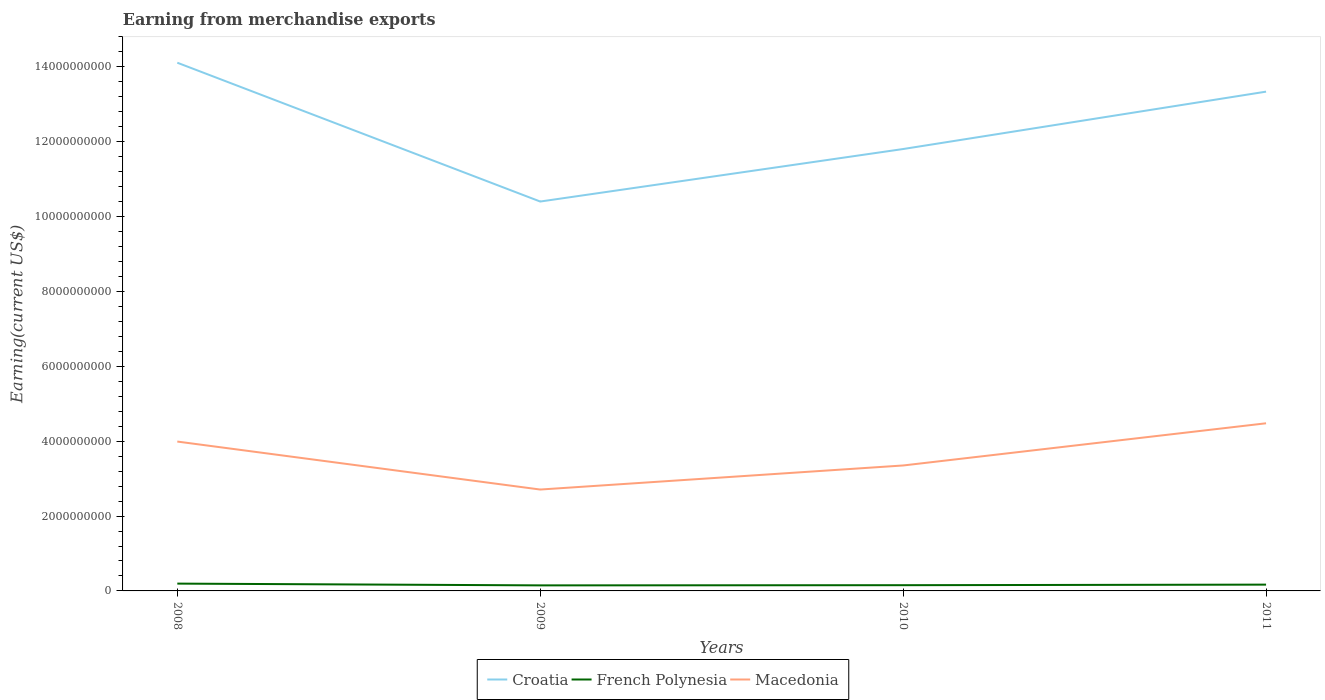How many different coloured lines are there?
Ensure brevity in your answer.  3. Is the number of lines equal to the number of legend labels?
Keep it short and to the point. Yes. Across all years, what is the maximum amount earned from merchandise exports in Croatia?
Ensure brevity in your answer.  1.04e+1. In which year was the amount earned from merchandise exports in Croatia maximum?
Make the answer very short. 2009. What is the total amount earned from merchandise exports in Croatia in the graph?
Keep it short and to the point. -2.94e+09. What is the difference between the highest and the second highest amount earned from merchandise exports in French Polynesia?
Ensure brevity in your answer.  4.72e+07. What is the difference between the highest and the lowest amount earned from merchandise exports in Macedonia?
Your response must be concise. 2. How many lines are there?
Provide a succinct answer. 3. Does the graph contain any zero values?
Give a very brief answer. No. Does the graph contain grids?
Provide a succinct answer. No. Where does the legend appear in the graph?
Provide a succinct answer. Bottom center. How many legend labels are there?
Your answer should be compact. 3. How are the legend labels stacked?
Keep it short and to the point. Horizontal. What is the title of the graph?
Your answer should be very brief. Earning from merchandise exports. What is the label or title of the X-axis?
Provide a succinct answer. Years. What is the label or title of the Y-axis?
Your answer should be very brief. Earning(current US$). What is the Earning(current US$) of Croatia in 2008?
Your answer should be very brief. 1.41e+1. What is the Earning(current US$) of French Polynesia in 2008?
Ensure brevity in your answer.  1.95e+08. What is the Earning(current US$) of Macedonia in 2008?
Your response must be concise. 3.99e+09. What is the Earning(current US$) of Croatia in 2009?
Offer a terse response. 1.04e+1. What is the Earning(current US$) of French Polynesia in 2009?
Your response must be concise. 1.48e+08. What is the Earning(current US$) in Macedonia in 2009?
Provide a short and direct response. 2.71e+09. What is the Earning(current US$) in Croatia in 2010?
Your answer should be very brief. 1.18e+1. What is the Earning(current US$) in French Polynesia in 2010?
Make the answer very short. 1.53e+08. What is the Earning(current US$) of Macedonia in 2010?
Give a very brief answer. 3.35e+09. What is the Earning(current US$) in Croatia in 2011?
Give a very brief answer. 1.33e+1. What is the Earning(current US$) in French Polynesia in 2011?
Give a very brief answer. 1.68e+08. What is the Earning(current US$) in Macedonia in 2011?
Your answer should be compact. 4.48e+09. Across all years, what is the maximum Earning(current US$) in Croatia?
Make the answer very short. 1.41e+1. Across all years, what is the maximum Earning(current US$) in French Polynesia?
Your response must be concise. 1.95e+08. Across all years, what is the maximum Earning(current US$) of Macedonia?
Your response must be concise. 4.48e+09. Across all years, what is the minimum Earning(current US$) of Croatia?
Your answer should be compact. 1.04e+1. Across all years, what is the minimum Earning(current US$) of French Polynesia?
Offer a very short reply. 1.48e+08. Across all years, what is the minimum Earning(current US$) in Macedonia?
Provide a succinct answer. 2.71e+09. What is the total Earning(current US$) in Croatia in the graph?
Your answer should be very brief. 4.97e+1. What is the total Earning(current US$) of French Polynesia in the graph?
Give a very brief answer. 6.65e+08. What is the total Earning(current US$) in Macedonia in the graph?
Ensure brevity in your answer.  1.45e+1. What is the difference between the Earning(current US$) of Croatia in 2008 and that in 2009?
Offer a terse response. 3.71e+09. What is the difference between the Earning(current US$) in French Polynesia in 2008 and that in 2009?
Provide a short and direct response. 4.72e+07. What is the difference between the Earning(current US$) in Macedonia in 2008 and that in 2009?
Keep it short and to the point. 1.28e+09. What is the difference between the Earning(current US$) in Croatia in 2008 and that in 2010?
Your answer should be very brief. 2.31e+09. What is the difference between the Earning(current US$) in French Polynesia in 2008 and that in 2010?
Keep it short and to the point. 4.23e+07. What is the difference between the Earning(current US$) in Macedonia in 2008 and that in 2010?
Provide a succinct answer. 6.39e+08. What is the difference between the Earning(current US$) of Croatia in 2008 and that in 2011?
Your response must be concise. 7.73e+08. What is the difference between the Earning(current US$) of French Polynesia in 2008 and that in 2011?
Offer a terse response. 2.75e+07. What is the difference between the Earning(current US$) in Macedonia in 2008 and that in 2011?
Make the answer very short. -4.88e+08. What is the difference between the Earning(current US$) in Croatia in 2009 and that in 2010?
Give a very brief answer. -1.40e+09. What is the difference between the Earning(current US$) in French Polynesia in 2009 and that in 2010?
Provide a short and direct response. -4.92e+06. What is the difference between the Earning(current US$) of Macedonia in 2009 and that in 2010?
Provide a succinct answer. -6.43e+08. What is the difference between the Earning(current US$) of Croatia in 2009 and that in 2011?
Keep it short and to the point. -2.94e+09. What is the difference between the Earning(current US$) in French Polynesia in 2009 and that in 2011?
Provide a succinct answer. -1.98e+07. What is the difference between the Earning(current US$) of Macedonia in 2009 and that in 2011?
Ensure brevity in your answer.  -1.77e+09. What is the difference between the Earning(current US$) in Croatia in 2010 and that in 2011?
Keep it short and to the point. -1.53e+09. What is the difference between the Earning(current US$) of French Polynesia in 2010 and that in 2011?
Ensure brevity in your answer.  -1.48e+07. What is the difference between the Earning(current US$) in Macedonia in 2010 and that in 2011?
Your response must be concise. -1.13e+09. What is the difference between the Earning(current US$) in Croatia in 2008 and the Earning(current US$) in French Polynesia in 2009?
Make the answer very short. 1.40e+1. What is the difference between the Earning(current US$) of Croatia in 2008 and the Earning(current US$) of Macedonia in 2009?
Offer a very short reply. 1.14e+1. What is the difference between the Earning(current US$) in French Polynesia in 2008 and the Earning(current US$) in Macedonia in 2009?
Keep it short and to the point. -2.51e+09. What is the difference between the Earning(current US$) of Croatia in 2008 and the Earning(current US$) of French Polynesia in 2010?
Offer a very short reply. 1.40e+1. What is the difference between the Earning(current US$) in Croatia in 2008 and the Earning(current US$) in Macedonia in 2010?
Provide a succinct answer. 1.08e+1. What is the difference between the Earning(current US$) in French Polynesia in 2008 and the Earning(current US$) in Macedonia in 2010?
Provide a short and direct response. -3.16e+09. What is the difference between the Earning(current US$) of Croatia in 2008 and the Earning(current US$) of French Polynesia in 2011?
Ensure brevity in your answer.  1.39e+1. What is the difference between the Earning(current US$) of Croatia in 2008 and the Earning(current US$) of Macedonia in 2011?
Offer a very short reply. 9.63e+09. What is the difference between the Earning(current US$) of French Polynesia in 2008 and the Earning(current US$) of Macedonia in 2011?
Your answer should be compact. -4.28e+09. What is the difference between the Earning(current US$) of Croatia in 2009 and the Earning(current US$) of French Polynesia in 2010?
Provide a succinct answer. 1.02e+1. What is the difference between the Earning(current US$) in Croatia in 2009 and the Earning(current US$) in Macedonia in 2010?
Your answer should be very brief. 7.05e+09. What is the difference between the Earning(current US$) of French Polynesia in 2009 and the Earning(current US$) of Macedonia in 2010?
Offer a very short reply. -3.20e+09. What is the difference between the Earning(current US$) in Croatia in 2009 and the Earning(current US$) in French Polynesia in 2011?
Your answer should be compact. 1.02e+1. What is the difference between the Earning(current US$) in Croatia in 2009 and the Earning(current US$) in Macedonia in 2011?
Ensure brevity in your answer.  5.92e+09. What is the difference between the Earning(current US$) in French Polynesia in 2009 and the Earning(current US$) in Macedonia in 2011?
Offer a very short reply. -4.33e+09. What is the difference between the Earning(current US$) of Croatia in 2010 and the Earning(current US$) of French Polynesia in 2011?
Provide a short and direct response. 1.16e+1. What is the difference between the Earning(current US$) of Croatia in 2010 and the Earning(current US$) of Macedonia in 2011?
Keep it short and to the point. 7.33e+09. What is the difference between the Earning(current US$) of French Polynesia in 2010 and the Earning(current US$) of Macedonia in 2011?
Provide a succinct answer. -4.33e+09. What is the average Earning(current US$) of Croatia per year?
Keep it short and to the point. 1.24e+1. What is the average Earning(current US$) of French Polynesia per year?
Provide a short and direct response. 1.66e+08. What is the average Earning(current US$) of Macedonia per year?
Your answer should be compact. 3.63e+09. In the year 2008, what is the difference between the Earning(current US$) of Croatia and Earning(current US$) of French Polynesia?
Your answer should be compact. 1.39e+1. In the year 2008, what is the difference between the Earning(current US$) in Croatia and Earning(current US$) in Macedonia?
Your answer should be very brief. 1.01e+1. In the year 2008, what is the difference between the Earning(current US$) in French Polynesia and Earning(current US$) in Macedonia?
Your answer should be very brief. -3.80e+09. In the year 2009, what is the difference between the Earning(current US$) in Croatia and Earning(current US$) in French Polynesia?
Provide a short and direct response. 1.03e+1. In the year 2009, what is the difference between the Earning(current US$) in Croatia and Earning(current US$) in Macedonia?
Give a very brief answer. 7.69e+09. In the year 2009, what is the difference between the Earning(current US$) of French Polynesia and Earning(current US$) of Macedonia?
Provide a short and direct response. -2.56e+09. In the year 2010, what is the difference between the Earning(current US$) of Croatia and Earning(current US$) of French Polynesia?
Ensure brevity in your answer.  1.17e+1. In the year 2010, what is the difference between the Earning(current US$) of Croatia and Earning(current US$) of Macedonia?
Keep it short and to the point. 8.45e+09. In the year 2010, what is the difference between the Earning(current US$) in French Polynesia and Earning(current US$) in Macedonia?
Provide a short and direct response. -3.20e+09. In the year 2011, what is the difference between the Earning(current US$) of Croatia and Earning(current US$) of French Polynesia?
Ensure brevity in your answer.  1.32e+1. In the year 2011, what is the difference between the Earning(current US$) of Croatia and Earning(current US$) of Macedonia?
Your answer should be compact. 8.86e+09. In the year 2011, what is the difference between the Earning(current US$) of French Polynesia and Earning(current US$) of Macedonia?
Provide a short and direct response. -4.31e+09. What is the ratio of the Earning(current US$) of Croatia in 2008 to that in 2009?
Offer a terse response. 1.36. What is the ratio of the Earning(current US$) of French Polynesia in 2008 to that in 2009?
Your answer should be compact. 1.32. What is the ratio of the Earning(current US$) of Macedonia in 2008 to that in 2009?
Give a very brief answer. 1.47. What is the ratio of the Earning(current US$) in Croatia in 2008 to that in 2010?
Keep it short and to the point. 1.2. What is the ratio of the Earning(current US$) in French Polynesia in 2008 to that in 2010?
Offer a terse response. 1.28. What is the ratio of the Earning(current US$) in Macedonia in 2008 to that in 2010?
Offer a terse response. 1.19. What is the ratio of the Earning(current US$) of Croatia in 2008 to that in 2011?
Your answer should be very brief. 1.06. What is the ratio of the Earning(current US$) of French Polynesia in 2008 to that in 2011?
Offer a very short reply. 1.16. What is the ratio of the Earning(current US$) in Macedonia in 2008 to that in 2011?
Your answer should be very brief. 0.89. What is the ratio of the Earning(current US$) of Croatia in 2009 to that in 2010?
Your answer should be compact. 0.88. What is the ratio of the Earning(current US$) in French Polynesia in 2009 to that in 2010?
Give a very brief answer. 0.97. What is the ratio of the Earning(current US$) in Macedonia in 2009 to that in 2010?
Ensure brevity in your answer.  0.81. What is the ratio of the Earning(current US$) of Croatia in 2009 to that in 2011?
Your answer should be very brief. 0.78. What is the ratio of the Earning(current US$) of French Polynesia in 2009 to that in 2011?
Offer a very short reply. 0.88. What is the ratio of the Earning(current US$) of Macedonia in 2009 to that in 2011?
Your answer should be very brief. 0.6. What is the ratio of the Earning(current US$) in Croatia in 2010 to that in 2011?
Provide a short and direct response. 0.89. What is the ratio of the Earning(current US$) in French Polynesia in 2010 to that in 2011?
Give a very brief answer. 0.91. What is the ratio of the Earning(current US$) in Macedonia in 2010 to that in 2011?
Give a very brief answer. 0.75. What is the difference between the highest and the second highest Earning(current US$) of Croatia?
Provide a succinct answer. 7.73e+08. What is the difference between the highest and the second highest Earning(current US$) in French Polynesia?
Give a very brief answer. 2.75e+07. What is the difference between the highest and the second highest Earning(current US$) of Macedonia?
Your response must be concise. 4.88e+08. What is the difference between the highest and the lowest Earning(current US$) of Croatia?
Provide a succinct answer. 3.71e+09. What is the difference between the highest and the lowest Earning(current US$) of French Polynesia?
Provide a succinct answer. 4.72e+07. What is the difference between the highest and the lowest Earning(current US$) of Macedonia?
Offer a very short reply. 1.77e+09. 